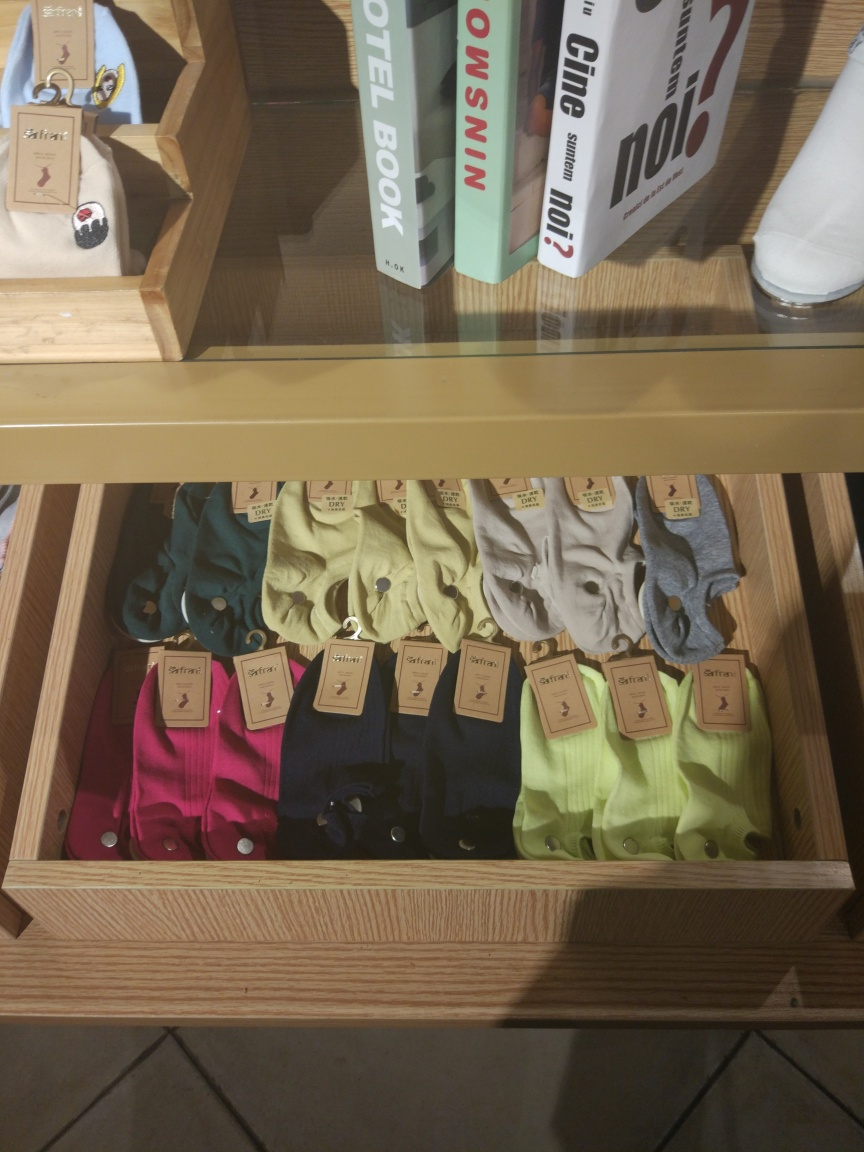What does the presentation of items tell us about the store? The organized and minimalist presentation suggests that the store emphasizes a clean and structured shopping experience. Displaying shirts in a single drawer with labels facing outward makes it easy for customers to browse through the options. The inclusion of books and lifestyle magazines indicates a curated product selection, perhaps aiming to attract a customer base interested in fashion as well as culture or design. 